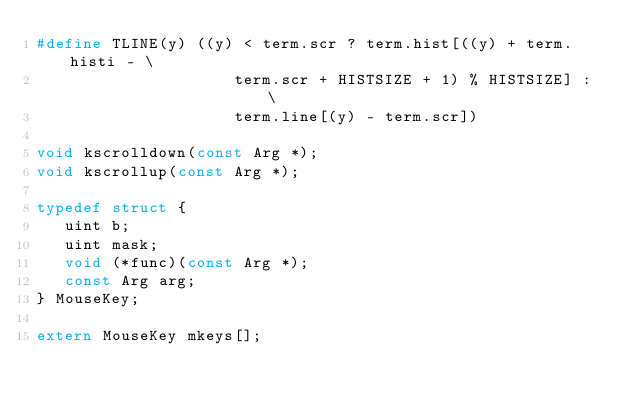Convert code to text. <code><loc_0><loc_0><loc_500><loc_500><_C_>#define TLINE(y) ((y) < term.scr ? term.hist[((y) + term.histi - \
                     term.scr + HISTSIZE + 1) % HISTSIZE] : \
                     term.line[(y) - term.scr])

void kscrolldown(const Arg *);
void kscrollup(const Arg *);

typedef struct {
	 uint b;
	 uint mask;
	 void (*func)(const Arg *);
	 const Arg arg;
} MouseKey;

extern MouseKey mkeys[];

</code> 